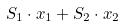<formula> <loc_0><loc_0><loc_500><loc_500>S _ { 1 } \cdot x _ { 1 } + S _ { 2 } \cdot x _ { 2 }</formula> 